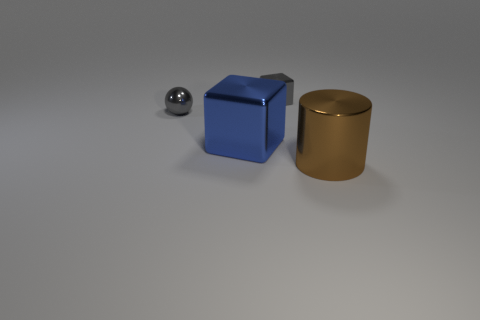How many large brown cylinders are behind the small gray shiny sphere?
Keep it short and to the point. 0. How many other objects are the same size as the brown shiny thing?
Give a very brief answer. 1. Is the material of the tiny thing to the right of the sphere the same as the big thing that is left of the brown thing?
Make the answer very short. Yes. What color is the shiny thing that is the same size as the cylinder?
Provide a succinct answer. Blue. Is there any other thing of the same color as the small shiny sphere?
Provide a short and direct response. Yes. What size is the gray thing that is on the left side of the gray shiny thing that is to the right of the big object left of the big brown thing?
Provide a succinct answer. Small. There is a object that is both right of the big blue metal object and behind the large brown metallic cylinder; what color is it?
Provide a succinct answer. Gray. What size is the blue metallic block that is on the right side of the gray ball?
Provide a short and direct response. Large. What number of objects have the same material as the large block?
Give a very brief answer. 3. There is a thing that is the same color as the tiny block; what is its shape?
Offer a terse response. Sphere. 